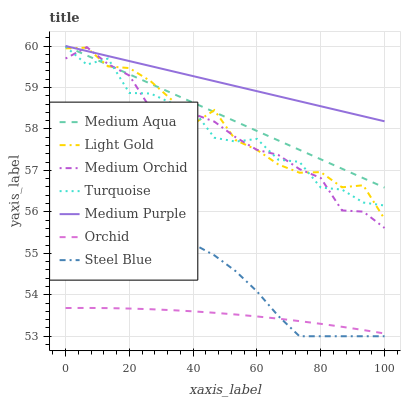Does Orchid have the minimum area under the curve?
Answer yes or no. Yes. Does Medium Purple have the maximum area under the curve?
Answer yes or no. Yes. Does Medium Orchid have the minimum area under the curve?
Answer yes or no. No. Does Medium Orchid have the maximum area under the curve?
Answer yes or no. No. Is Medium Aqua the smoothest?
Answer yes or no. Yes. Is Turquoise the roughest?
Answer yes or no. Yes. Is Medium Orchid the smoothest?
Answer yes or no. No. Is Medium Orchid the roughest?
Answer yes or no. No. Does Steel Blue have the lowest value?
Answer yes or no. Yes. Does Medium Orchid have the lowest value?
Answer yes or no. No. Does Medium Aqua have the highest value?
Answer yes or no. Yes. Does Medium Orchid have the highest value?
Answer yes or no. No. Is Turquoise less than Medium Purple?
Answer yes or no. Yes. Is Turquoise greater than Orchid?
Answer yes or no. Yes. Does Light Gold intersect Medium Purple?
Answer yes or no. Yes. Is Light Gold less than Medium Purple?
Answer yes or no. No. Is Light Gold greater than Medium Purple?
Answer yes or no. No. Does Turquoise intersect Medium Purple?
Answer yes or no. No. 